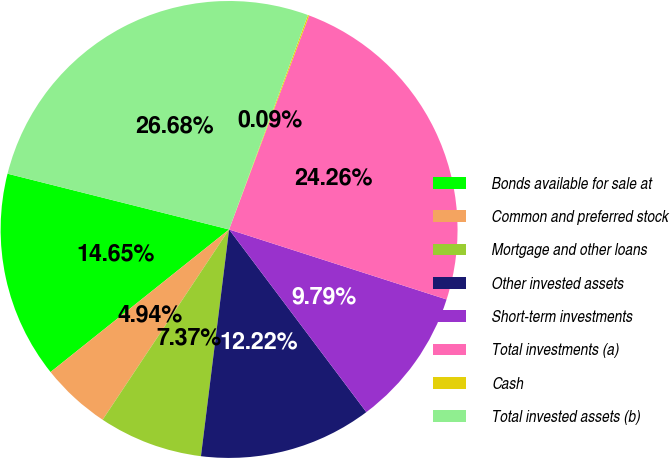Convert chart. <chart><loc_0><loc_0><loc_500><loc_500><pie_chart><fcel>Bonds available for sale at<fcel>Common and preferred stock<fcel>Mortgage and other loans<fcel>Other invested assets<fcel>Short-term investments<fcel>Total investments (a)<fcel>Cash<fcel>Total invested assets (b)<nl><fcel>14.65%<fcel>4.94%<fcel>7.37%<fcel>12.22%<fcel>9.79%<fcel>24.26%<fcel>0.09%<fcel>26.68%<nl></chart> 